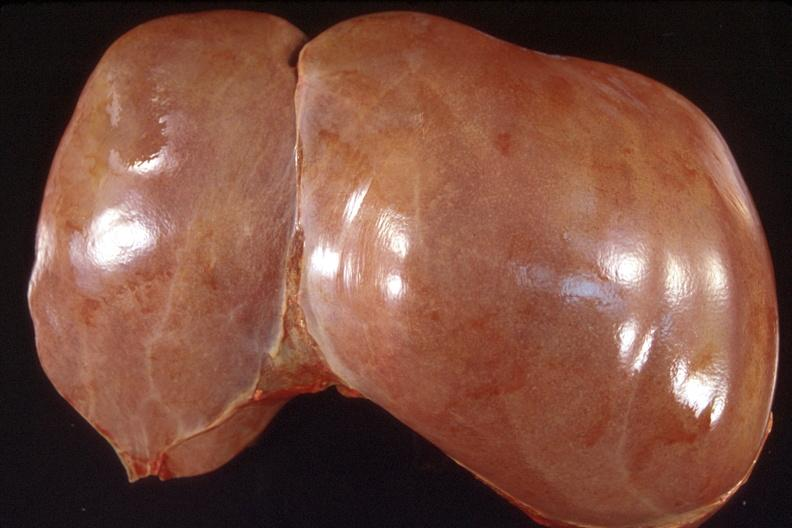s hepatobiliary present?
Answer the question using a single word or phrase. Yes 